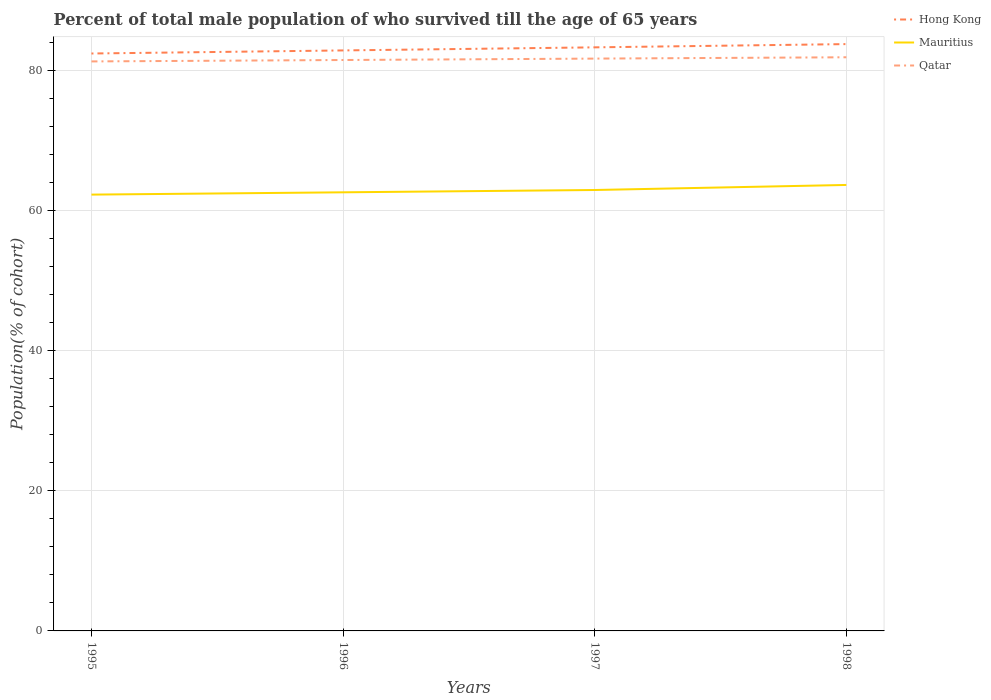How many different coloured lines are there?
Keep it short and to the point. 3. Does the line corresponding to Mauritius intersect with the line corresponding to Qatar?
Offer a very short reply. No. Is the number of lines equal to the number of legend labels?
Ensure brevity in your answer.  Yes. Across all years, what is the maximum percentage of total male population who survived till the age of 65 years in Qatar?
Offer a very short reply. 81.31. In which year was the percentage of total male population who survived till the age of 65 years in Hong Kong maximum?
Give a very brief answer. 1995. What is the total percentage of total male population who survived till the age of 65 years in Hong Kong in the graph?
Keep it short and to the point. -0.44. What is the difference between the highest and the second highest percentage of total male population who survived till the age of 65 years in Qatar?
Make the answer very short. 0.59. What is the difference between the highest and the lowest percentage of total male population who survived till the age of 65 years in Mauritius?
Provide a succinct answer. 2. How many lines are there?
Your answer should be compact. 3. How many years are there in the graph?
Ensure brevity in your answer.  4. Does the graph contain any zero values?
Provide a short and direct response. No. Does the graph contain grids?
Offer a very short reply. Yes. Where does the legend appear in the graph?
Provide a short and direct response. Top right. How many legend labels are there?
Ensure brevity in your answer.  3. What is the title of the graph?
Provide a succinct answer. Percent of total male population of who survived till the age of 65 years. Does "Lithuania" appear as one of the legend labels in the graph?
Keep it short and to the point. No. What is the label or title of the Y-axis?
Your answer should be very brief. Population(% of cohort). What is the Population(% of cohort) of Hong Kong in 1995?
Your response must be concise. 82.44. What is the Population(% of cohort) in Mauritius in 1995?
Your response must be concise. 62.3. What is the Population(% of cohort) in Qatar in 1995?
Your response must be concise. 81.31. What is the Population(% of cohort) in Hong Kong in 1996?
Keep it short and to the point. 82.88. What is the Population(% of cohort) of Mauritius in 1996?
Offer a terse response. 62.62. What is the Population(% of cohort) in Qatar in 1996?
Offer a terse response. 81.51. What is the Population(% of cohort) of Hong Kong in 1997?
Your answer should be very brief. 83.32. What is the Population(% of cohort) in Mauritius in 1997?
Your answer should be very brief. 62.95. What is the Population(% of cohort) in Qatar in 1997?
Your answer should be compact. 81.72. What is the Population(% of cohort) of Hong Kong in 1998?
Your answer should be very brief. 83.79. What is the Population(% of cohort) in Mauritius in 1998?
Provide a short and direct response. 63.67. What is the Population(% of cohort) of Qatar in 1998?
Offer a very short reply. 81.9. Across all years, what is the maximum Population(% of cohort) in Hong Kong?
Keep it short and to the point. 83.79. Across all years, what is the maximum Population(% of cohort) of Mauritius?
Your answer should be compact. 63.67. Across all years, what is the maximum Population(% of cohort) of Qatar?
Ensure brevity in your answer.  81.9. Across all years, what is the minimum Population(% of cohort) in Hong Kong?
Your answer should be very brief. 82.44. Across all years, what is the minimum Population(% of cohort) in Mauritius?
Keep it short and to the point. 62.3. Across all years, what is the minimum Population(% of cohort) of Qatar?
Make the answer very short. 81.31. What is the total Population(% of cohort) of Hong Kong in the graph?
Provide a short and direct response. 332.43. What is the total Population(% of cohort) of Mauritius in the graph?
Keep it short and to the point. 251.55. What is the total Population(% of cohort) of Qatar in the graph?
Provide a succinct answer. 326.45. What is the difference between the Population(% of cohort) of Hong Kong in 1995 and that in 1996?
Your response must be concise. -0.44. What is the difference between the Population(% of cohort) of Mauritius in 1995 and that in 1996?
Your answer should be compact. -0.33. What is the difference between the Population(% of cohort) in Qatar in 1995 and that in 1996?
Your answer should be compact. -0.2. What is the difference between the Population(% of cohort) in Hong Kong in 1995 and that in 1997?
Your answer should be compact. -0.88. What is the difference between the Population(% of cohort) of Mauritius in 1995 and that in 1997?
Offer a terse response. -0.66. What is the difference between the Population(% of cohort) of Qatar in 1995 and that in 1997?
Offer a very short reply. -0.4. What is the difference between the Population(% of cohort) in Hong Kong in 1995 and that in 1998?
Offer a terse response. -1.34. What is the difference between the Population(% of cohort) of Mauritius in 1995 and that in 1998?
Offer a very short reply. -1.38. What is the difference between the Population(% of cohort) in Qatar in 1995 and that in 1998?
Your answer should be compact. -0.59. What is the difference between the Population(% of cohort) in Hong Kong in 1996 and that in 1997?
Make the answer very short. -0.44. What is the difference between the Population(% of cohort) of Mauritius in 1996 and that in 1997?
Keep it short and to the point. -0.33. What is the difference between the Population(% of cohort) in Qatar in 1996 and that in 1997?
Offer a terse response. -0.2. What is the difference between the Population(% of cohort) in Hong Kong in 1996 and that in 1998?
Provide a succinct answer. -0.9. What is the difference between the Population(% of cohort) in Mauritius in 1996 and that in 1998?
Give a very brief answer. -1.05. What is the difference between the Population(% of cohort) in Qatar in 1996 and that in 1998?
Keep it short and to the point. -0.39. What is the difference between the Population(% of cohort) in Hong Kong in 1997 and that in 1998?
Provide a short and direct response. -0.46. What is the difference between the Population(% of cohort) in Mauritius in 1997 and that in 1998?
Your answer should be compact. -0.72. What is the difference between the Population(% of cohort) of Qatar in 1997 and that in 1998?
Give a very brief answer. -0.19. What is the difference between the Population(% of cohort) of Hong Kong in 1995 and the Population(% of cohort) of Mauritius in 1996?
Your response must be concise. 19.82. What is the difference between the Population(% of cohort) of Hong Kong in 1995 and the Population(% of cohort) of Qatar in 1996?
Ensure brevity in your answer.  0.93. What is the difference between the Population(% of cohort) in Mauritius in 1995 and the Population(% of cohort) in Qatar in 1996?
Offer a very short reply. -19.22. What is the difference between the Population(% of cohort) in Hong Kong in 1995 and the Population(% of cohort) in Mauritius in 1997?
Your answer should be very brief. 19.49. What is the difference between the Population(% of cohort) of Hong Kong in 1995 and the Population(% of cohort) of Qatar in 1997?
Offer a terse response. 0.73. What is the difference between the Population(% of cohort) in Mauritius in 1995 and the Population(% of cohort) in Qatar in 1997?
Your response must be concise. -19.42. What is the difference between the Population(% of cohort) of Hong Kong in 1995 and the Population(% of cohort) of Mauritius in 1998?
Ensure brevity in your answer.  18.77. What is the difference between the Population(% of cohort) of Hong Kong in 1995 and the Population(% of cohort) of Qatar in 1998?
Provide a succinct answer. 0.54. What is the difference between the Population(% of cohort) of Mauritius in 1995 and the Population(% of cohort) of Qatar in 1998?
Make the answer very short. -19.61. What is the difference between the Population(% of cohort) of Hong Kong in 1996 and the Population(% of cohort) of Mauritius in 1997?
Give a very brief answer. 19.93. What is the difference between the Population(% of cohort) of Hong Kong in 1996 and the Population(% of cohort) of Qatar in 1997?
Your answer should be very brief. 1.17. What is the difference between the Population(% of cohort) in Mauritius in 1996 and the Population(% of cohort) in Qatar in 1997?
Your response must be concise. -19.09. What is the difference between the Population(% of cohort) in Hong Kong in 1996 and the Population(% of cohort) in Mauritius in 1998?
Make the answer very short. 19.21. What is the difference between the Population(% of cohort) in Hong Kong in 1996 and the Population(% of cohort) in Qatar in 1998?
Your answer should be compact. 0.98. What is the difference between the Population(% of cohort) in Mauritius in 1996 and the Population(% of cohort) in Qatar in 1998?
Your answer should be compact. -19.28. What is the difference between the Population(% of cohort) in Hong Kong in 1997 and the Population(% of cohort) in Mauritius in 1998?
Your answer should be very brief. 19.65. What is the difference between the Population(% of cohort) of Hong Kong in 1997 and the Population(% of cohort) of Qatar in 1998?
Your response must be concise. 1.42. What is the difference between the Population(% of cohort) in Mauritius in 1997 and the Population(% of cohort) in Qatar in 1998?
Give a very brief answer. -18.95. What is the average Population(% of cohort) in Hong Kong per year?
Provide a succinct answer. 83.11. What is the average Population(% of cohort) of Mauritius per year?
Give a very brief answer. 62.89. What is the average Population(% of cohort) in Qatar per year?
Give a very brief answer. 81.61. In the year 1995, what is the difference between the Population(% of cohort) in Hong Kong and Population(% of cohort) in Mauritius?
Make the answer very short. 20.15. In the year 1995, what is the difference between the Population(% of cohort) of Hong Kong and Population(% of cohort) of Qatar?
Make the answer very short. 1.13. In the year 1995, what is the difference between the Population(% of cohort) in Mauritius and Population(% of cohort) in Qatar?
Offer a terse response. -19.02. In the year 1996, what is the difference between the Population(% of cohort) of Hong Kong and Population(% of cohort) of Mauritius?
Offer a very short reply. 20.26. In the year 1996, what is the difference between the Population(% of cohort) of Hong Kong and Population(% of cohort) of Qatar?
Make the answer very short. 1.37. In the year 1996, what is the difference between the Population(% of cohort) of Mauritius and Population(% of cohort) of Qatar?
Your answer should be compact. -18.89. In the year 1997, what is the difference between the Population(% of cohort) of Hong Kong and Population(% of cohort) of Mauritius?
Provide a short and direct response. 20.37. In the year 1997, what is the difference between the Population(% of cohort) in Hong Kong and Population(% of cohort) in Qatar?
Provide a short and direct response. 1.61. In the year 1997, what is the difference between the Population(% of cohort) in Mauritius and Population(% of cohort) in Qatar?
Offer a very short reply. -18.76. In the year 1998, what is the difference between the Population(% of cohort) in Hong Kong and Population(% of cohort) in Mauritius?
Your answer should be very brief. 20.11. In the year 1998, what is the difference between the Population(% of cohort) of Hong Kong and Population(% of cohort) of Qatar?
Offer a terse response. 1.88. In the year 1998, what is the difference between the Population(% of cohort) of Mauritius and Population(% of cohort) of Qatar?
Your answer should be very brief. -18.23. What is the ratio of the Population(% of cohort) in Qatar in 1995 to that in 1996?
Provide a succinct answer. 1. What is the ratio of the Population(% of cohort) in Hong Kong in 1995 to that in 1997?
Your answer should be compact. 0.99. What is the ratio of the Population(% of cohort) in Mauritius in 1995 to that in 1997?
Provide a short and direct response. 0.99. What is the ratio of the Population(% of cohort) of Qatar in 1995 to that in 1997?
Give a very brief answer. 1. What is the ratio of the Population(% of cohort) in Hong Kong in 1995 to that in 1998?
Offer a terse response. 0.98. What is the ratio of the Population(% of cohort) in Mauritius in 1995 to that in 1998?
Your response must be concise. 0.98. What is the ratio of the Population(% of cohort) in Qatar in 1995 to that in 1998?
Your answer should be very brief. 0.99. What is the ratio of the Population(% of cohort) in Mauritius in 1996 to that in 1998?
Keep it short and to the point. 0.98. What is the ratio of the Population(% of cohort) in Qatar in 1996 to that in 1998?
Ensure brevity in your answer.  1. What is the ratio of the Population(% of cohort) in Hong Kong in 1997 to that in 1998?
Give a very brief answer. 0.99. What is the ratio of the Population(% of cohort) in Mauritius in 1997 to that in 1998?
Your answer should be compact. 0.99. What is the ratio of the Population(% of cohort) of Qatar in 1997 to that in 1998?
Your response must be concise. 1. What is the difference between the highest and the second highest Population(% of cohort) of Hong Kong?
Offer a very short reply. 0.46. What is the difference between the highest and the second highest Population(% of cohort) of Mauritius?
Ensure brevity in your answer.  0.72. What is the difference between the highest and the second highest Population(% of cohort) of Qatar?
Give a very brief answer. 0.19. What is the difference between the highest and the lowest Population(% of cohort) of Hong Kong?
Offer a very short reply. 1.34. What is the difference between the highest and the lowest Population(% of cohort) of Mauritius?
Offer a very short reply. 1.38. What is the difference between the highest and the lowest Population(% of cohort) of Qatar?
Ensure brevity in your answer.  0.59. 